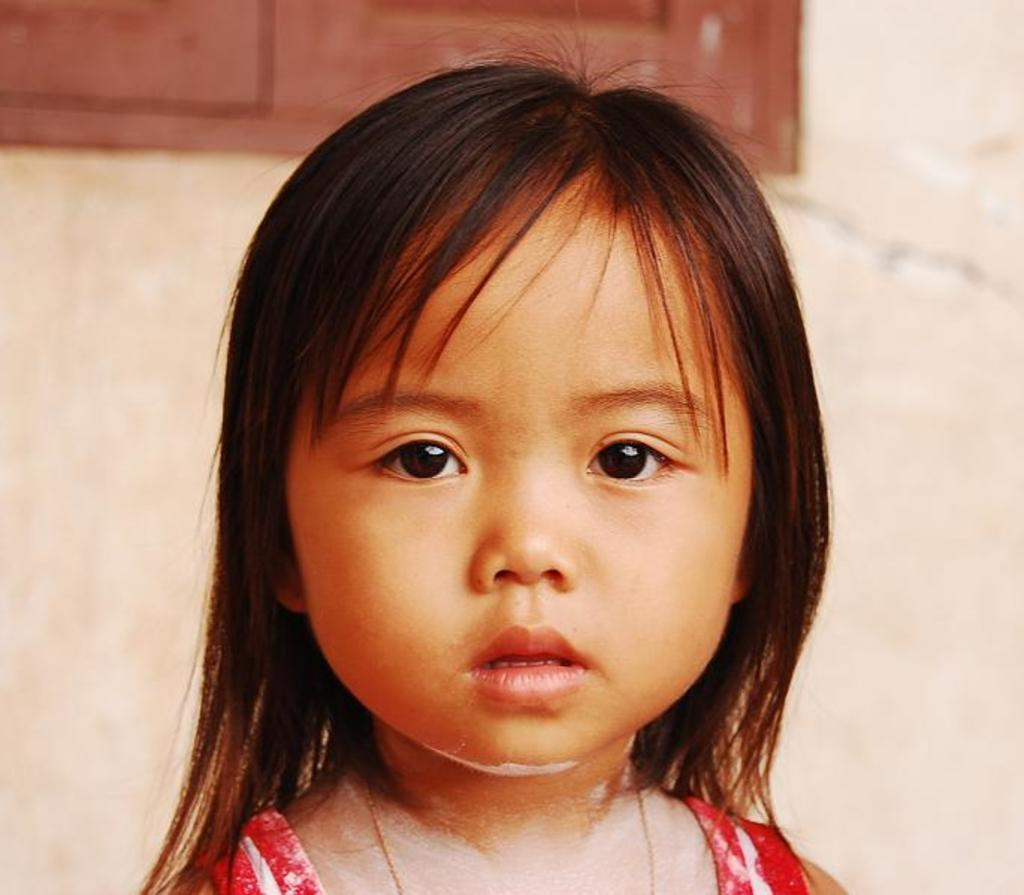Who is the main subject in the image? There is a little girl in the image. What is the girl wearing? The girl is wearing a red dress. Where is the girl standing? The girl is standing in front of a wall. What can be seen on the wall? There is a window on the left side of the wall. What type of rings can be seen on the girl's fingers in the image? There are no rings visible on the girl's fingers in the image. How does the sleet affect the girl's appearance in the image? There is no mention of sleet in the image, so it cannot affect the girl's appearance. 